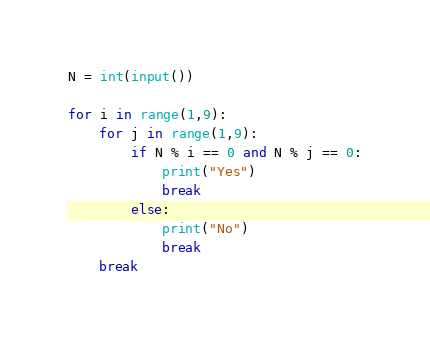Convert code to text. <code><loc_0><loc_0><loc_500><loc_500><_Python_>N = int(input())

for i in range(1,9):
    for j in range(1,9):
        if N % i == 0 and N % j == 0:
            print("Yes")
            break
        else:
            print("No")
            break
    break
</code> 